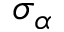<formula> <loc_0><loc_0><loc_500><loc_500>\sigma _ { \alpha }</formula> 